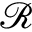Convert formula to latex. <formula><loc_0><loc_0><loc_500><loc_500>\mathcal { R }</formula> 